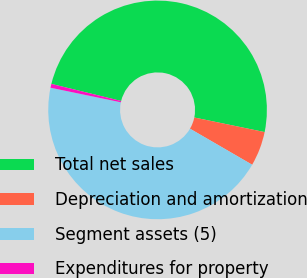<chart> <loc_0><loc_0><loc_500><loc_500><pie_chart><fcel>Total net sales<fcel>Depreciation and amortization<fcel>Segment assets (5)<fcel>Expenditures for property<nl><fcel>49.43%<fcel>5.11%<fcel>44.89%<fcel>0.57%<nl></chart> 